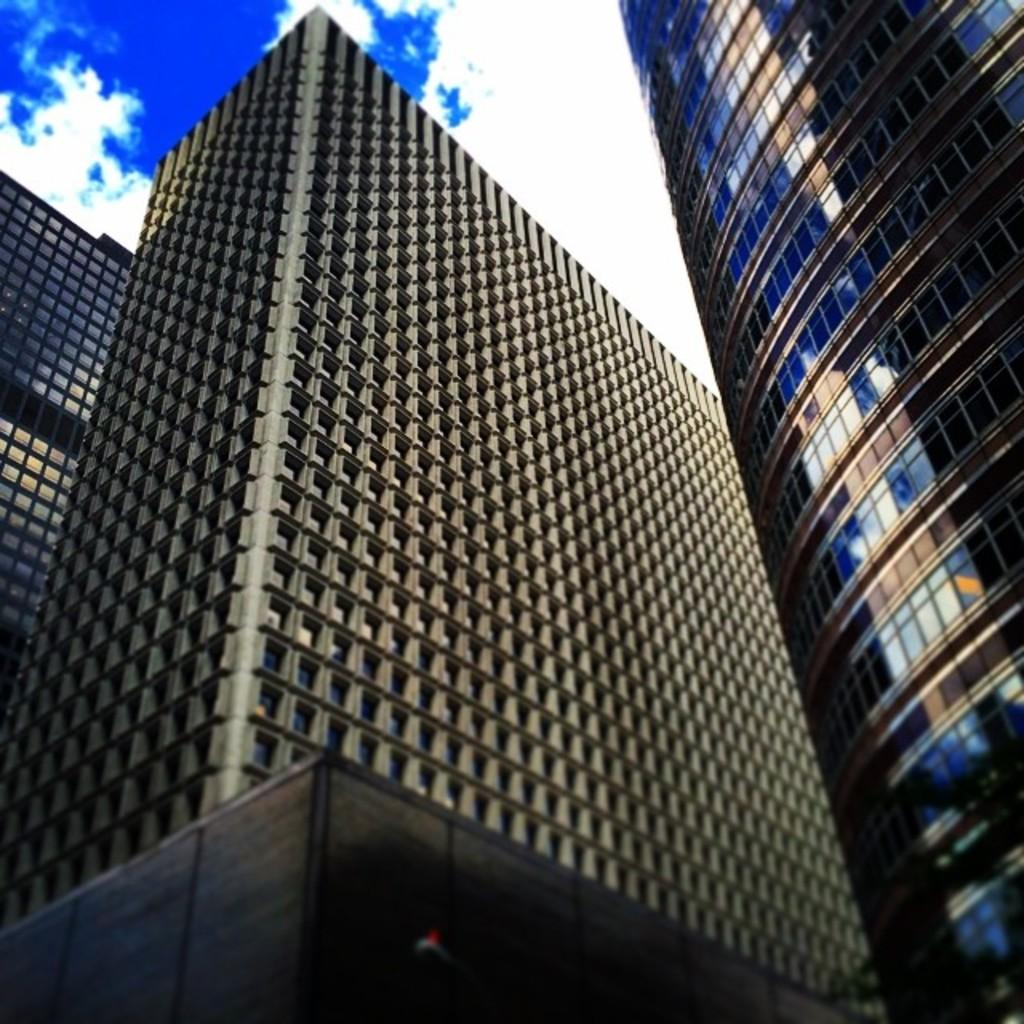What type of structures can be seen in the image? There are buildings in the image. What is visible in the background of the image? The sky is visible in the background of the image. What can be observed in the sky? There are clouds in the sky. What type of berry is growing on the roof of the building in the image? There is no berry growing on the roof of the building in the image. 